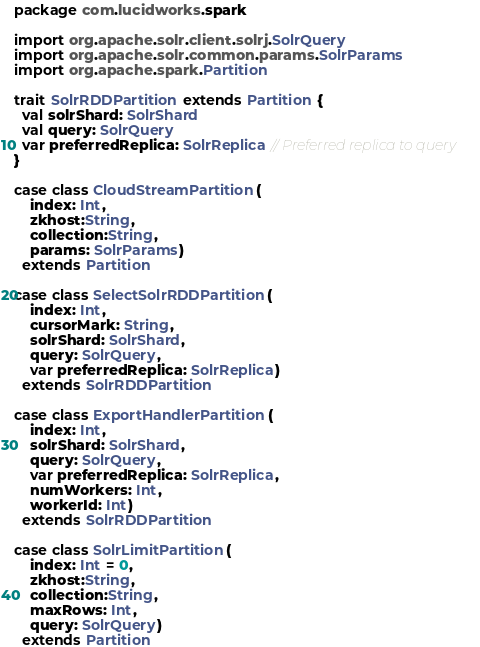<code> <loc_0><loc_0><loc_500><loc_500><_Scala_>package com.lucidworks.spark

import org.apache.solr.client.solrj.SolrQuery
import org.apache.solr.common.params.SolrParams
import org.apache.spark.Partition

trait SolrRDDPartition extends Partition {
  val solrShard: SolrShard
  val query: SolrQuery
  var preferredReplica: SolrReplica // Preferred replica to query
}

case class CloudStreamPartition(
    index: Int,
    zkhost:String,
    collection:String,
    params: SolrParams)
  extends Partition

case class SelectSolrRDDPartition(
    index: Int,
    cursorMark: String,
    solrShard: SolrShard,
    query: SolrQuery,
    var preferredReplica: SolrReplica)
  extends SolrRDDPartition

case class ExportHandlerPartition(
    index: Int,
    solrShard: SolrShard,
    query: SolrQuery,
    var preferredReplica: SolrReplica,
    numWorkers: Int,
    workerId: Int)
  extends SolrRDDPartition

case class SolrLimitPartition(
    index: Int = 0,
    zkhost:String,
    collection:String,
    maxRows: Int,
    query: SolrQuery)
  extends Partition
</code> 